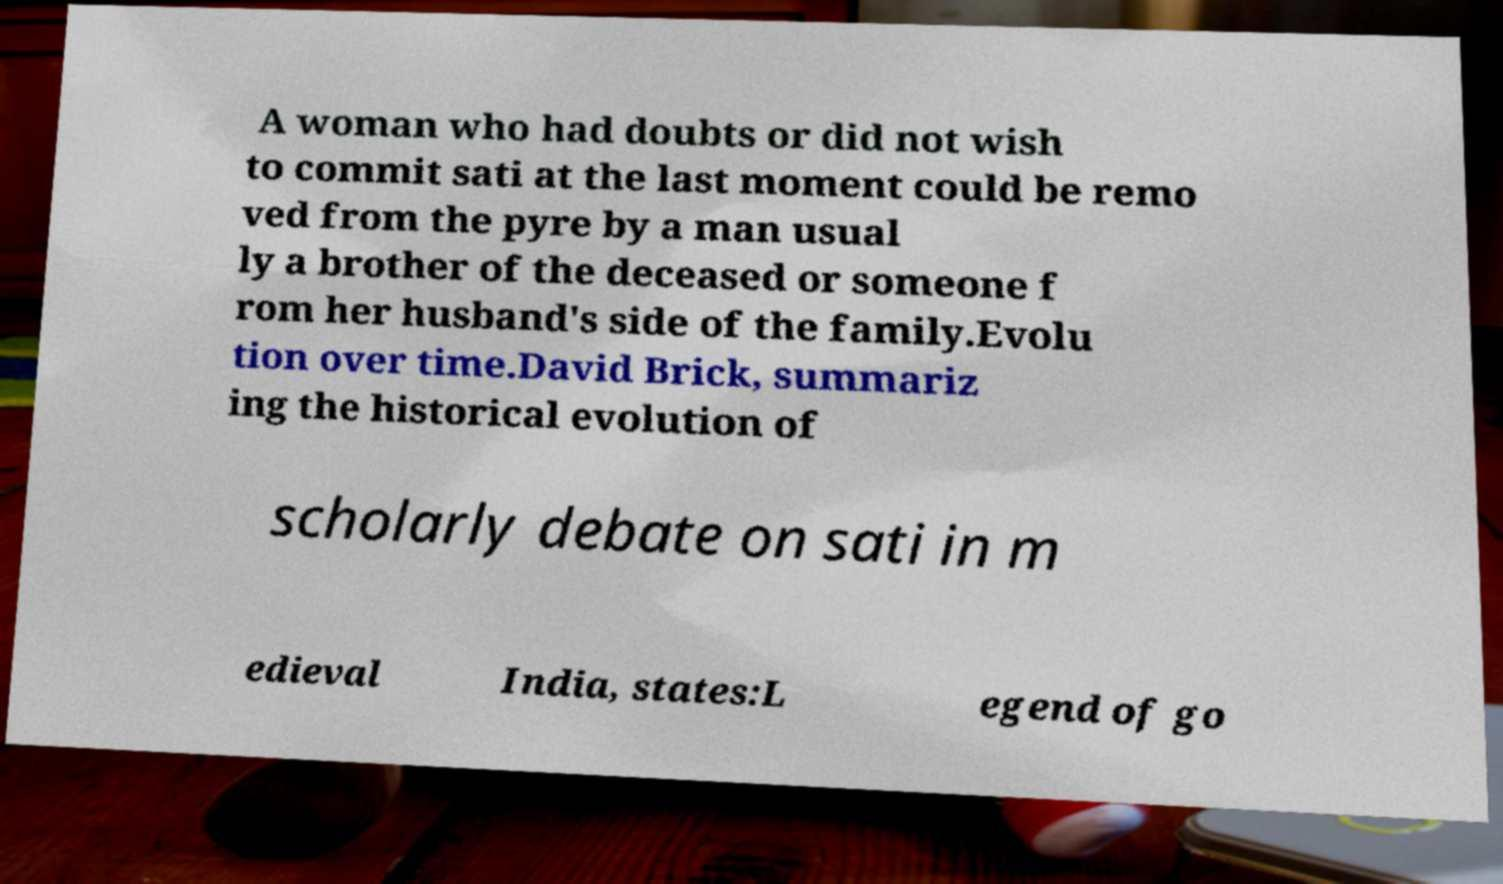Please read and relay the text visible in this image. What does it say? A woman who had doubts or did not wish to commit sati at the last moment could be remo ved from the pyre by a man usual ly a brother of the deceased or someone f rom her husband's side of the family.Evolu tion over time.David Brick, summariz ing the historical evolution of scholarly debate on sati in m edieval India, states:L egend of go 